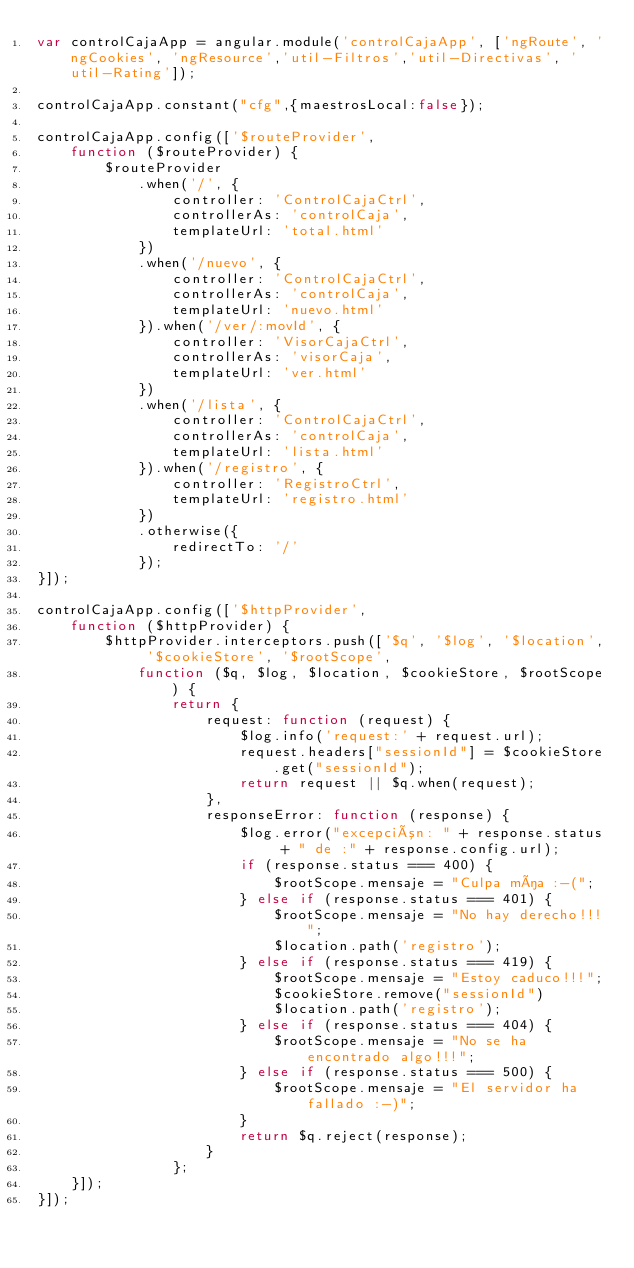<code> <loc_0><loc_0><loc_500><loc_500><_JavaScript_>var controlCajaApp = angular.module('controlCajaApp', ['ngRoute', 'ngCookies', 'ngResource','util-Filtros','util-Directivas', 'util-Rating']);

controlCajaApp.constant("cfg",{maestrosLocal:false});

controlCajaApp.config(['$routeProvider',
    function ($routeProvider) {
        $routeProvider
            .when('/', {
                controller: 'ControlCajaCtrl',
                controllerAs: 'controlCaja',
                templateUrl: 'total.html'
            })
            .when('/nuevo', {
                controller: 'ControlCajaCtrl',
                controllerAs: 'controlCaja',
                templateUrl: 'nuevo.html'
            }).when('/ver/:movId', {
                controller: 'VisorCajaCtrl',
                controllerAs: 'visorCaja',
                templateUrl: 'ver.html'
            })
            .when('/lista', {
                controller: 'ControlCajaCtrl',
                controllerAs: 'controlCaja',
                templateUrl: 'lista.html'
            }).when('/registro', {
                controller: 'RegistroCtrl',
                templateUrl: 'registro.html'
            })
            .otherwise({
                redirectTo: '/'
            });
}]);

controlCajaApp.config(['$httpProvider',
    function ($httpProvider) {
        $httpProvider.interceptors.push(['$q', '$log', '$location', '$cookieStore', '$rootScope',
            function ($q, $log, $location, $cookieStore, $rootScope) {
                return {
                    request: function (request) {
                        $log.info('request:' + request.url);
                        request.headers["sessionId"] = $cookieStore.get("sessionId");
                        return request || $q.when(request);
                    },
                    responseError: function (response) {
                        $log.error("excepción: " + response.status + " de :" + response.config.url);
                        if (response.status === 400) {
                            $rootScope.mensaje = "Culpa mía :-(";
                        } else if (response.status === 401) {
                            $rootScope.mensaje = "No hay derecho!!!";
                            $location.path('registro');
                        } else if (response.status === 419) {
                            $rootScope.mensaje = "Estoy caduco!!!";
                            $cookieStore.remove("sessionId")
                            $location.path('registro');
                        } else if (response.status === 404) {
                            $rootScope.mensaje = "No se ha encontrado algo!!!";
                        } else if (response.status === 500) {
                            $rootScope.mensaje = "El servidor ha fallado :-)";
                        }
                        return $q.reject(response);
                    }
                };
    }]);
}]);</code> 